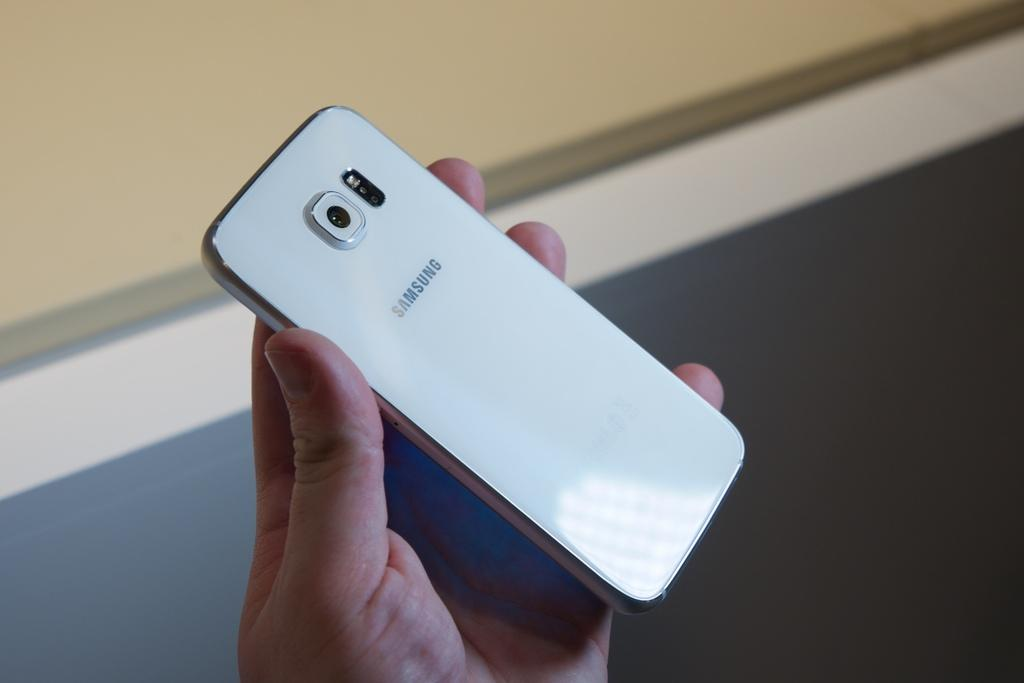<image>
Relay a brief, clear account of the picture shown. A white Samsung phone is being held in someone's hand. 